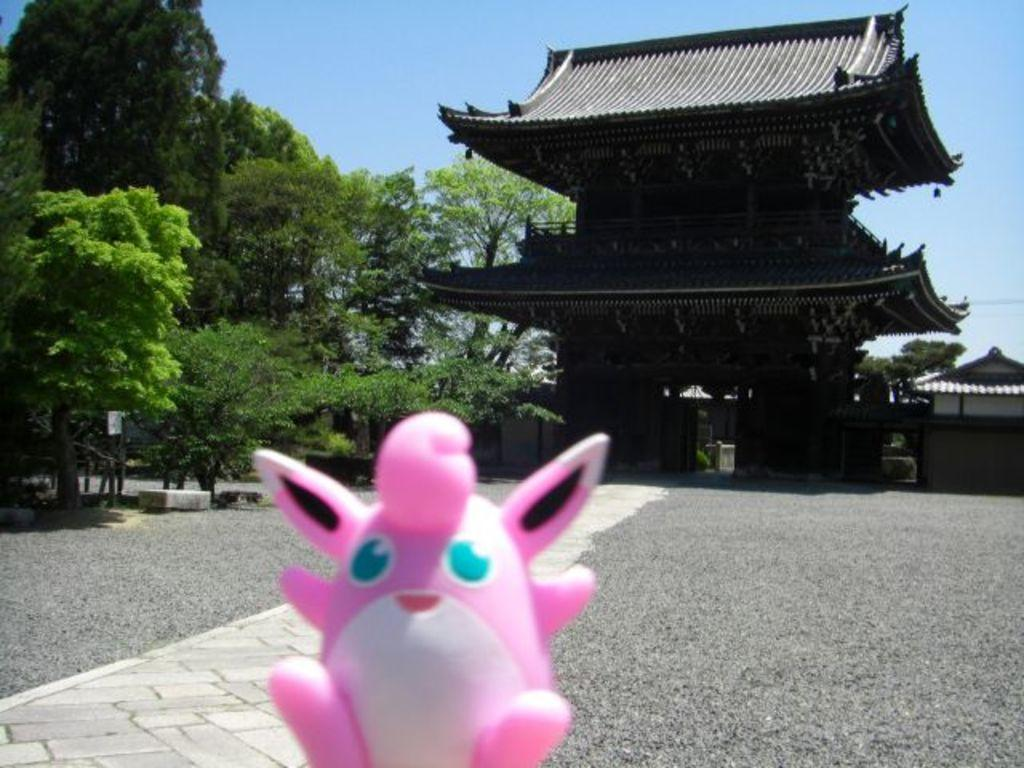What object can be seen in the foreground of the image? There is a toy in the image. What is located behind the toy in the image? There is a group of trees behind the toy. What type of structure is visible in the image? There is a house in the image. What is visible at the top of the image? The sky is visible at the top of the image. What songs are being played by the toy in the image? The toy in the image does not play songs, as it is a static object and not a musical instrument or device. 